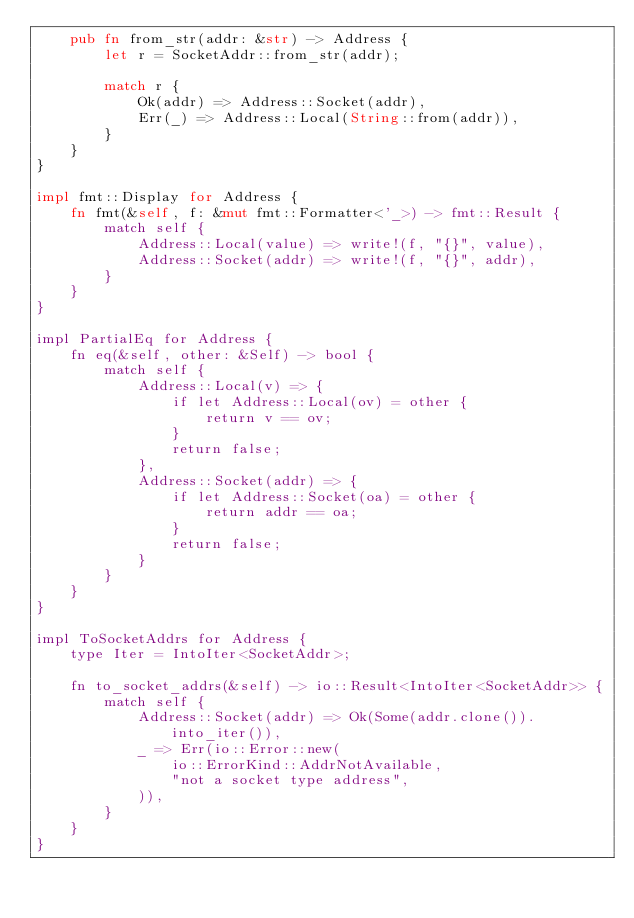Convert code to text. <code><loc_0><loc_0><loc_500><loc_500><_Rust_>    pub fn from_str(addr: &str) -> Address {
        let r = SocketAddr::from_str(addr);

        match r {
            Ok(addr) => Address::Socket(addr),
            Err(_) => Address::Local(String::from(addr)),
        }
    }
}

impl fmt::Display for Address {
    fn fmt(&self, f: &mut fmt::Formatter<'_>) -> fmt::Result {
        match self {
            Address::Local(value) => write!(f, "{}", value),
            Address::Socket(addr) => write!(f, "{}", addr),
        }
    }
}

impl PartialEq for Address {
    fn eq(&self, other: &Self) -> bool {
        match self {
            Address::Local(v) => {
                if let Address::Local(ov) = other {
                    return v == ov;
                }
                return false;
            },
            Address::Socket(addr) => {
                if let Address::Socket(oa) = other {
                    return addr == oa;
                }
                return false;
            }
        }
    }
}

impl ToSocketAddrs for Address {
    type Iter = IntoIter<SocketAddr>;

    fn to_socket_addrs(&self) -> io::Result<IntoIter<SocketAddr>> {
        match self {
            Address::Socket(addr) => Ok(Some(addr.clone()).into_iter()),
            _ => Err(io::Error::new(
                io::ErrorKind::AddrNotAvailable,
                "not a socket type address",
            )),
        }
    }
}
</code> 